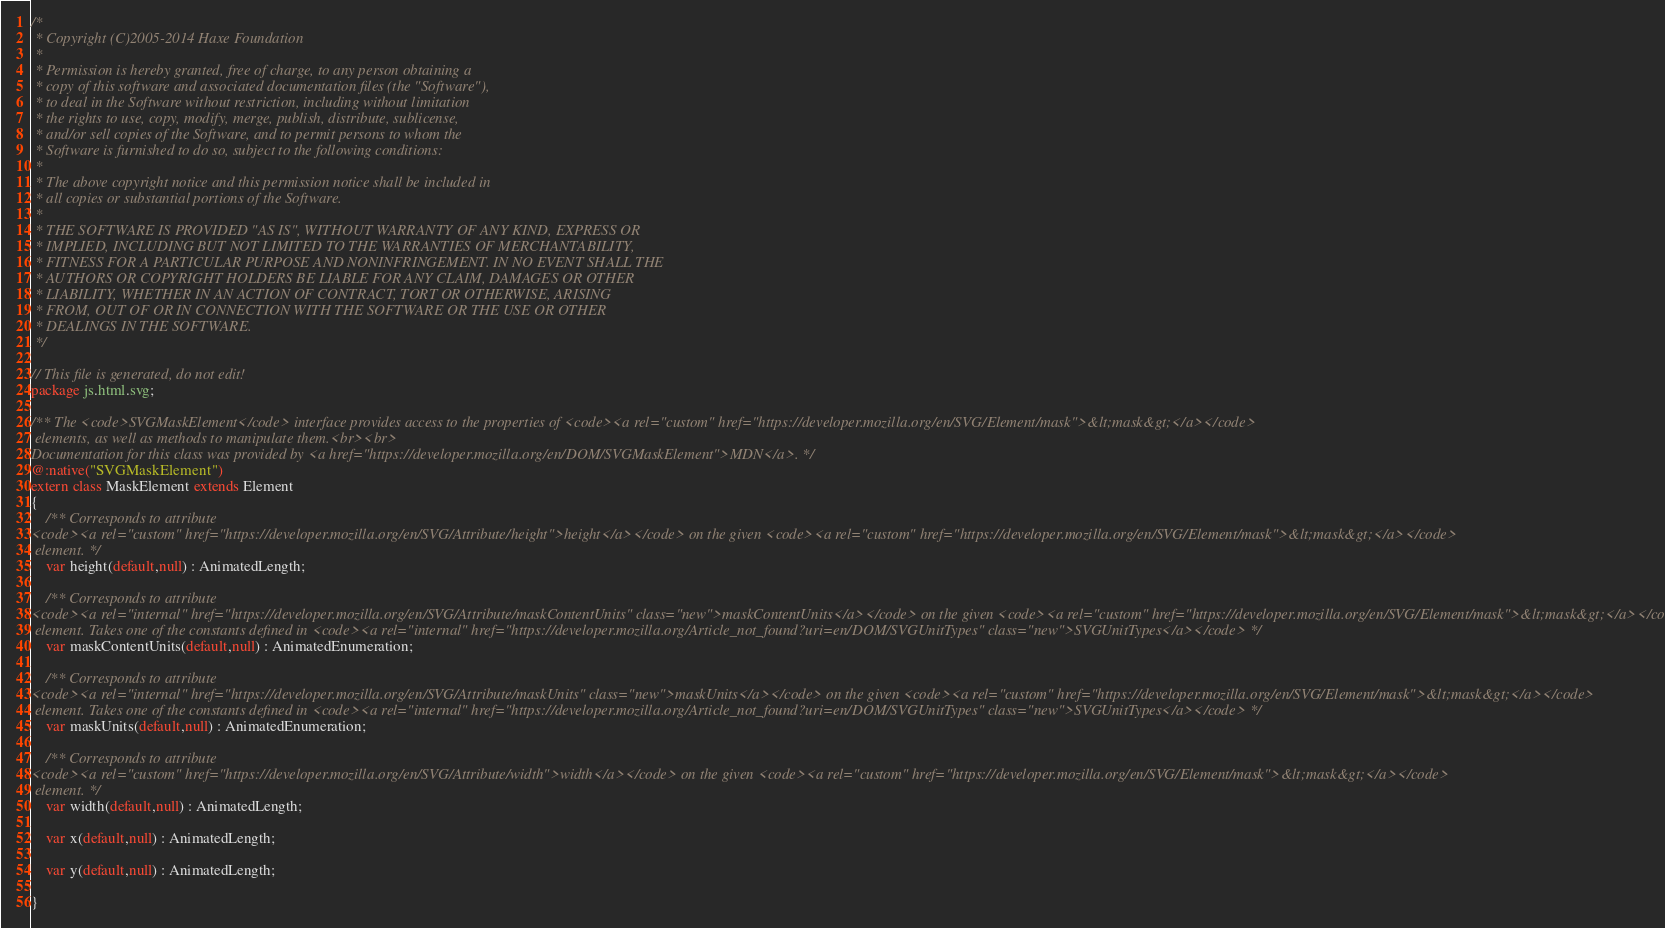<code> <loc_0><loc_0><loc_500><loc_500><_Haxe_>/*
 * Copyright (C)2005-2014 Haxe Foundation
 *
 * Permission is hereby granted, free of charge, to any person obtaining a
 * copy of this software and associated documentation files (the "Software"),
 * to deal in the Software without restriction, including without limitation
 * the rights to use, copy, modify, merge, publish, distribute, sublicense,
 * and/or sell copies of the Software, and to permit persons to whom the
 * Software is furnished to do so, subject to the following conditions:
 *
 * The above copyright notice and this permission notice shall be included in
 * all copies or substantial portions of the Software.
 *
 * THE SOFTWARE IS PROVIDED "AS IS", WITHOUT WARRANTY OF ANY KIND, EXPRESS OR
 * IMPLIED, INCLUDING BUT NOT LIMITED TO THE WARRANTIES OF MERCHANTABILITY,
 * FITNESS FOR A PARTICULAR PURPOSE AND NONINFRINGEMENT. IN NO EVENT SHALL THE
 * AUTHORS OR COPYRIGHT HOLDERS BE LIABLE FOR ANY CLAIM, DAMAGES OR OTHER
 * LIABILITY, WHETHER IN AN ACTION OF CONTRACT, TORT OR OTHERWISE, ARISING
 * FROM, OUT OF OR IN CONNECTION WITH THE SOFTWARE OR THE USE OR OTHER
 * DEALINGS IN THE SOFTWARE.
 */

// This file is generated, do not edit!
package js.html.svg;

/** The <code>SVGMaskElement</code> interface provides access to the properties of <code><a rel="custom" href="https://developer.mozilla.org/en/SVG/Element/mask">&lt;mask&gt;</a></code>
 elements, as well as methods to manipulate them.<br><br>
Documentation for this class was provided by <a href="https://developer.mozilla.org/en/DOM/SVGMaskElement">MDN</a>. */
@:native("SVGMaskElement")
extern class MaskElement extends Element
{
	/** Corresponds to attribute 
<code><a rel="custom" href="https://developer.mozilla.org/en/SVG/Attribute/height">height</a></code> on the given <code><a rel="custom" href="https://developer.mozilla.org/en/SVG/Element/mask">&lt;mask&gt;</a></code>
 element. */
	var height(default,null) : AnimatedLength;

	/** Corresponds to attribute 
<code><a rel="internal" href="https://developer.mozilla.org/en/SVG/Attribute/maskContentUnits" class="new">maskContentUnits</a></code> on the given <code><a rel="custom" href="https://developer.mozilla.org/en/SVG/Element/mask">&lt;mask&gt;</a></code>
 element. Takes one of the constants defined in <code><a rel="internal" href="https://developer.mozilla.org/Article_not_found?uri=en/DOM/SVGUnitTypes" class="new">SVGUnitTypes</a></code> */
	var maskContentUnits(default,null) : AnimatedEnumeration;

	/** Corresponds to attribute 
<code><a rel="internal" href="https://developer.mozilla.org/en/SVG/Attribute/maskUnits" class="new">maskUnits</a></code> on the given <code><a rel="custom" href="https://developer.mozilla.org/en/SVG/Element/mask">&lt;mask&gt;</a></code>
 element. Takes one of the constants defined in <code><a rel="internal" href="https://developer.mozilla.org/Article_not_found?uri=en/DOM/SVGUnitTypes" class="new">SVGUnitTypes</a></code> */
	var maskUnits(default,null) : AnimatedEnumeration;

	/** Corresponds to attribute 
<code><a rel="custom" href="https://developer.mozilla.org/en/SVG/Attribute/width">width</a></code> on the given <code><a rel="custom" href="https://developer.mozilla.org/en/SVG/Element/mask">&lt;mask&gt;</a></code>
 element. */
	var width(default,null) : AnimatedLength;

	var x(default,null) : AnimatedLength;

	var y(default,null) : AnimatedLength;

}
</code> 